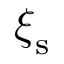Convert formula to latex. <formula><loc_0><loc_0><loc_500><loc_500>\xi _ { s }</formula> 